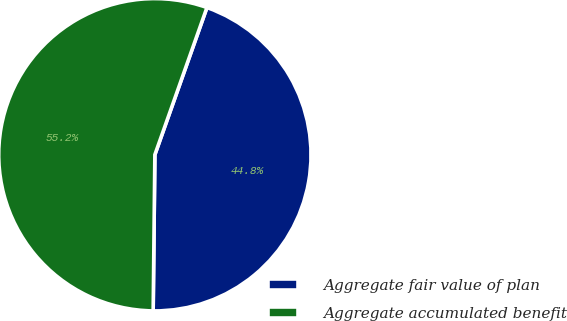Convert chart to OTSL. <chart><loc_0><loc_0><loc_500><loc_500><pie_chart><fcel>Aggregate fair value of plan<fcel>Aggregate accumulated benefit<nl><fcel>44.76%<fcel>55.24%<nl></chart> 